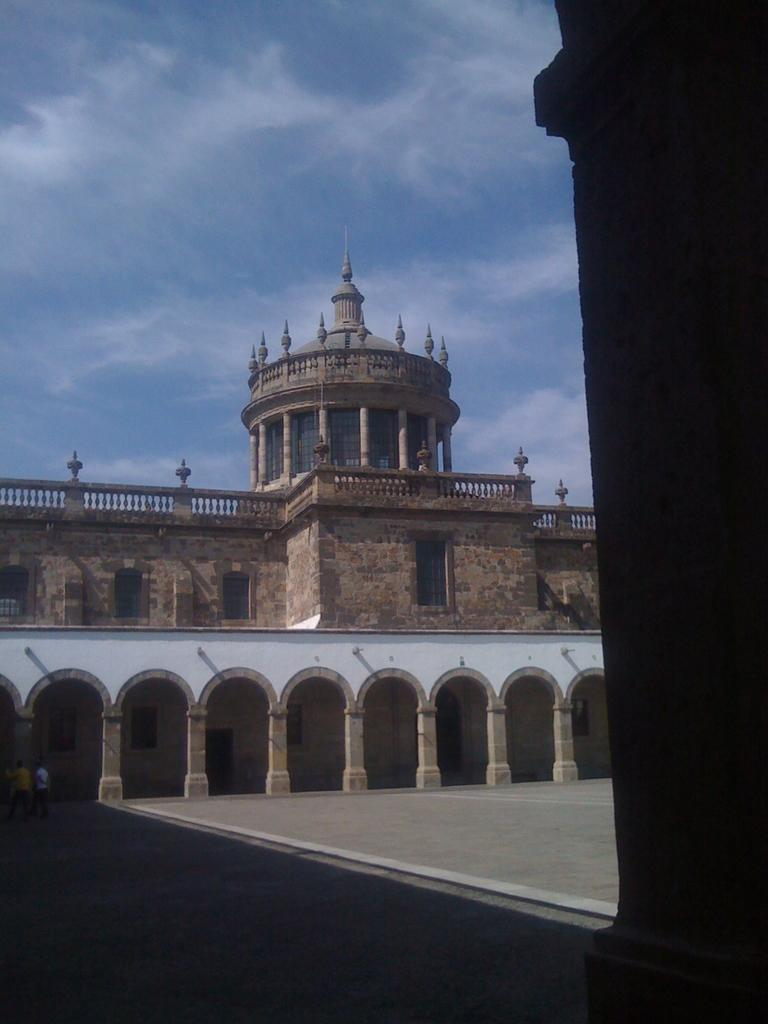What type of structure is in the image? There is a fort in the image. What are the rock pillars used for in the fort? The rock pillars are part of the fort's structure. Can you describe the people inside the fort? There are people inside the fort, but their specific activities or appearances cannot be determined from the image. What is visible at the top of the image? The sky is visible at the top of the image. What can be seen in the sky? There are clouds in the sky. What position does the body of the person inside the fort hold? There is no specific position mentioned for the person inside the fort, as their activities or postures cannot be determined from the image. 